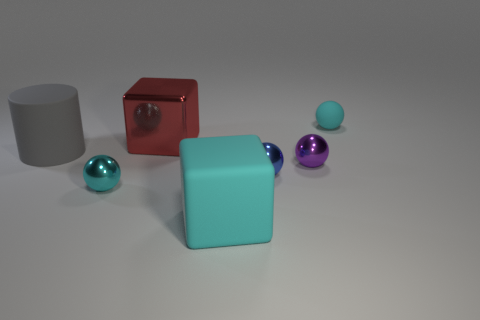There is a tiny thing that is behind the shiny object that is right of the blue object; what is its color?
Keep it short and to the point. Cyan. What material is the purple thing that is the same shape as the tiny blue shiny thing?
Keep it short and to the point. Metal. How many metallic objects are big cubes or balls?
Provide a short and direct response. 4. Do the cube that is behind the large cylinder and the small cyan ball that is right of the small purple object have the same material?
Ensure brevity in your answer.  No. Is there a tiny green matte ball?
Give a very brief answer. No. There is a cyan matte object in front of the tiny matte ball; is its shape the same as the cyan rubber thing behind the big cyan cube?
Your response must be concise. No. Is there a brown cylinder that has the same material as the small blue object?
Ensure brevity in your answer.  No. Is the small cyan sphere that is right of the small cyan metallic ball made of the same material as the large red object?
Provide a succinct answer. No. Are there more red metallic things right of the big red shiny object than gray matte objects right of the blue thing?
Provide a short and direct response. No. There is another matte thing that is the same size as the purple thing; what color is it?
Keep it short and to the point. Cyan. 